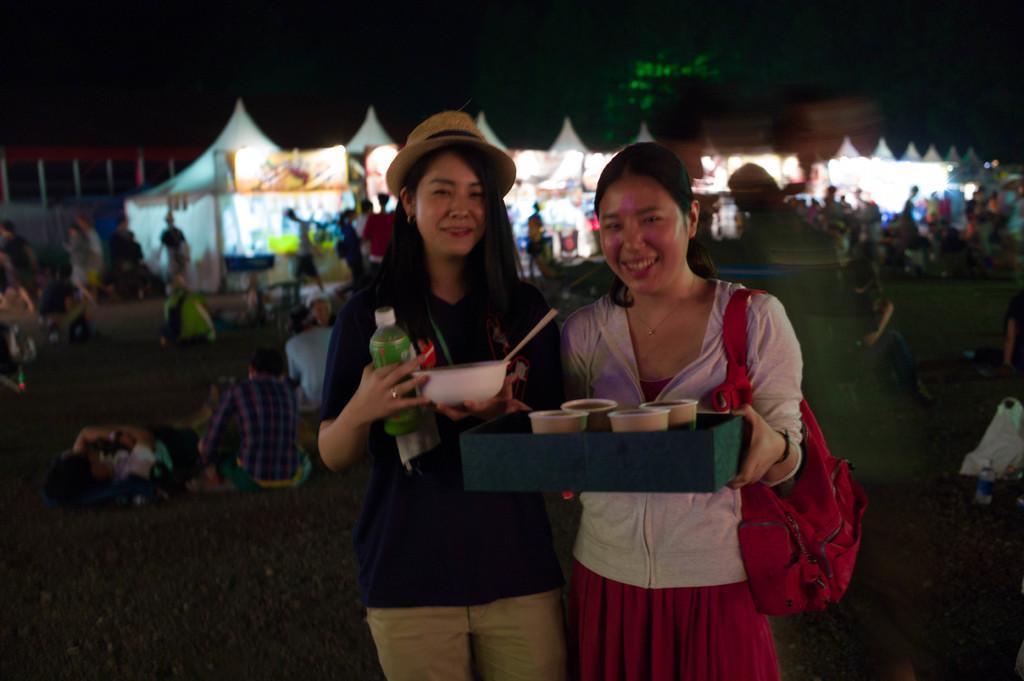Can you describe this image briefly? In this image we can see there are two people standing with a smile on their face and they are holding some objects and a bag in their hand, behind them there are a few people standing, walking and some are sitting on the floor. In the background there are few stalls. 